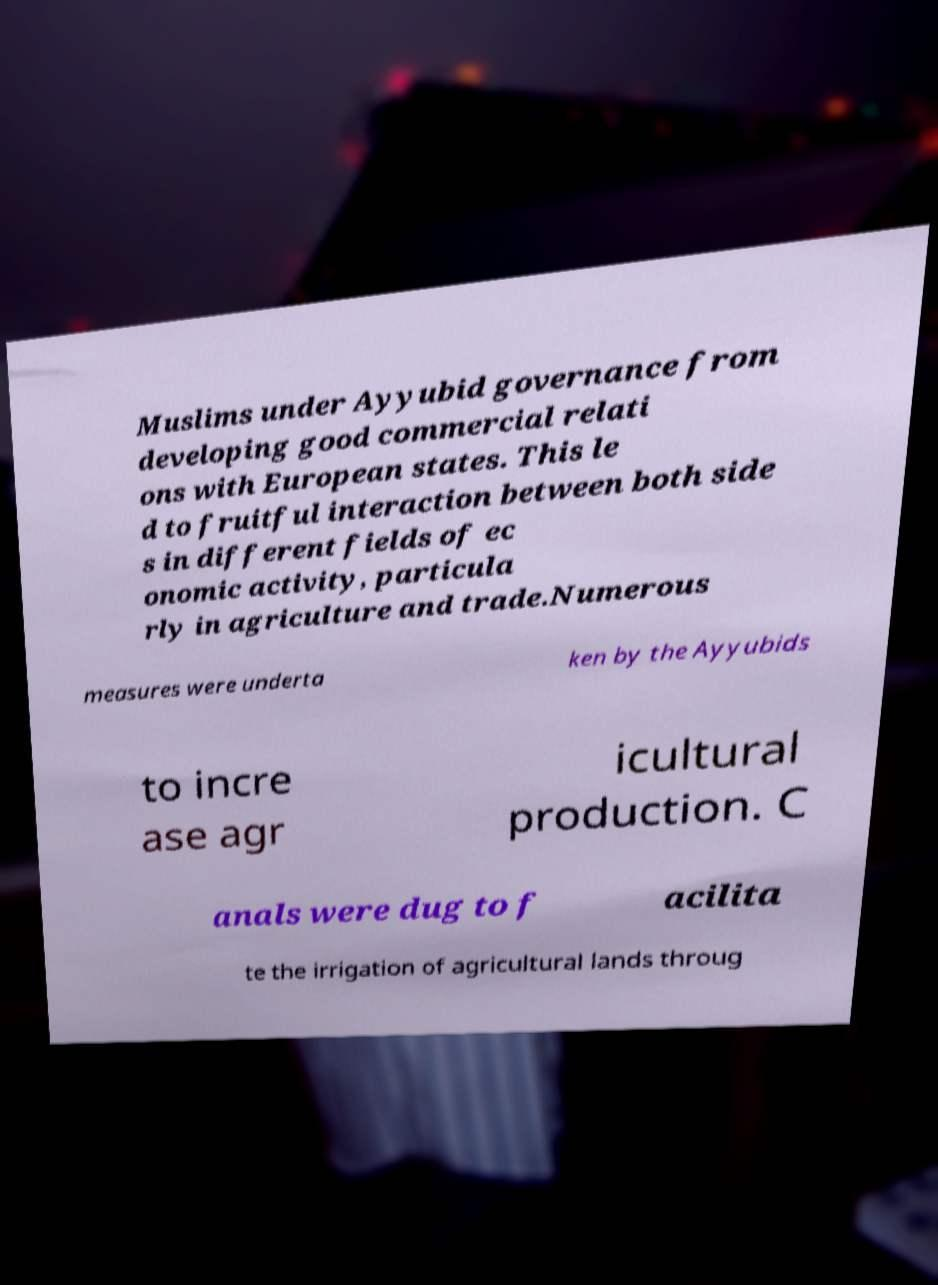Can you read and provide the text displayed in the image?This photo seems to have some interesting text. Can you extract and type it out for me? Muslims under Ayyubid governance from developing good commercial relati ons with European states. This le d to fruitful interaction between both side s in different fields of ec onomic activity, particula rly in agriculture and trade.Numerous measures were underta ken by the Ayyubids to incre ase agr icultural production. C anals were dug to f acilita te the irrigation of agricultural lands throug 